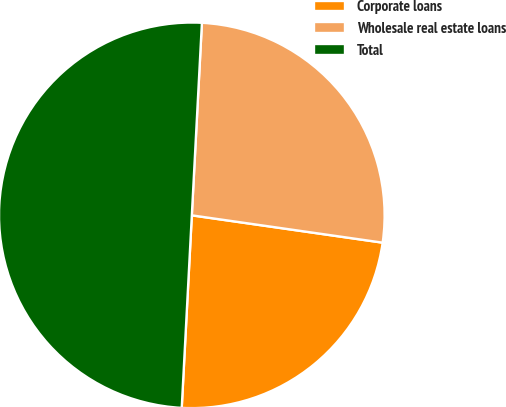Convert chart. <chart><loc_0><loc_0><loc_500><loc_500><pie_chart><fcel>Corporate loans<fcel>Wholesale real estate loans<fcel>Total<nl><fcel>23.57%<fcel>26.43%<fcel>50.0%<nl></chart> 